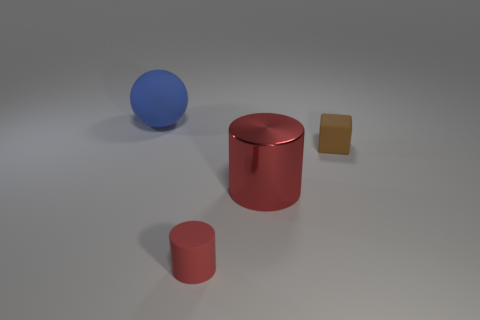Is there any other thing that has the same material as the small cylinder?
Give a very brief answer. Yes. The big object that is on the right side of the tiny thing that is in front of the red shiny thing is what color?
Your response must be concise. Red. What number of objects are big objects that are behind the large metallic thing or large things that are left of the metal cylinder?
Offer a terse response. 1. Is the sphere the same size as the brown rubber block?
Give a very brief answer. No. There is a big object that is in front of the large blue thing; is it the same shape as the tiny object that is behind the large red metal cylinder?
Provide a short and direct response. No. How big is the red metallic object?
Offer a very short reply. Large. What material is the cylinder in front of the big object that is to the right of the tiny rubber thing that is left of the block made of?
Offer a very short reply. Rubber. How many other objects are the same color as the cube?
Provide a succinct answer. 0. How many gray objects are small shiny cylinders or large matte things?
Keep it short and to the point. 0. What is the large thing in front of the blue sphere made of?
Keep it short and to the point. Metal. 